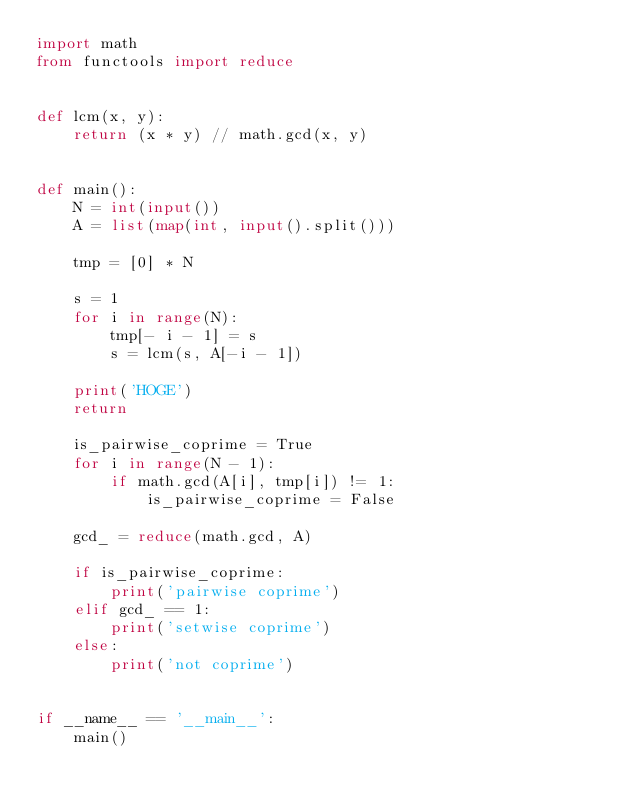<code> <loc_0><loc_0><loc_500><loc_500><_Python_>import math
from functools import reduce


def lcm(x, y):
    return (x * y) // math.gcd(x, y)


def main():
    N = int(input())
    A = list(map(int, input().split()))

    tmp = [0] * N

    s = 1
    for i in range(N):
        tmp[- i - 1] = s
        s = lcm(s, A[-i - 1])

    print('HOGE')
    return 

    is_pairwise_coprime = True
    for i in range(N - 1):
        if math.gcd(A[i], tmp[i]) != 1:
            is_pairwise_coprime = False

    gcd_ = reduce(math.gcd, A)

    if is_pairwise_coprime:
        print('pairwise coprime')
    elif gcd_ == 1:
        print('setwise coprime')
    else:
        print('not coprime')


if __name__ == '__main__':
    main()
</code> 